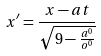<formula> <loc_0><loc_0><loc_500><loc_500>x ^ { \prime } = \frac { x - a t } { \sqrt { 9 - \frac { a ^ { 0 } } { o ^ { 0 } } } }</formula> 